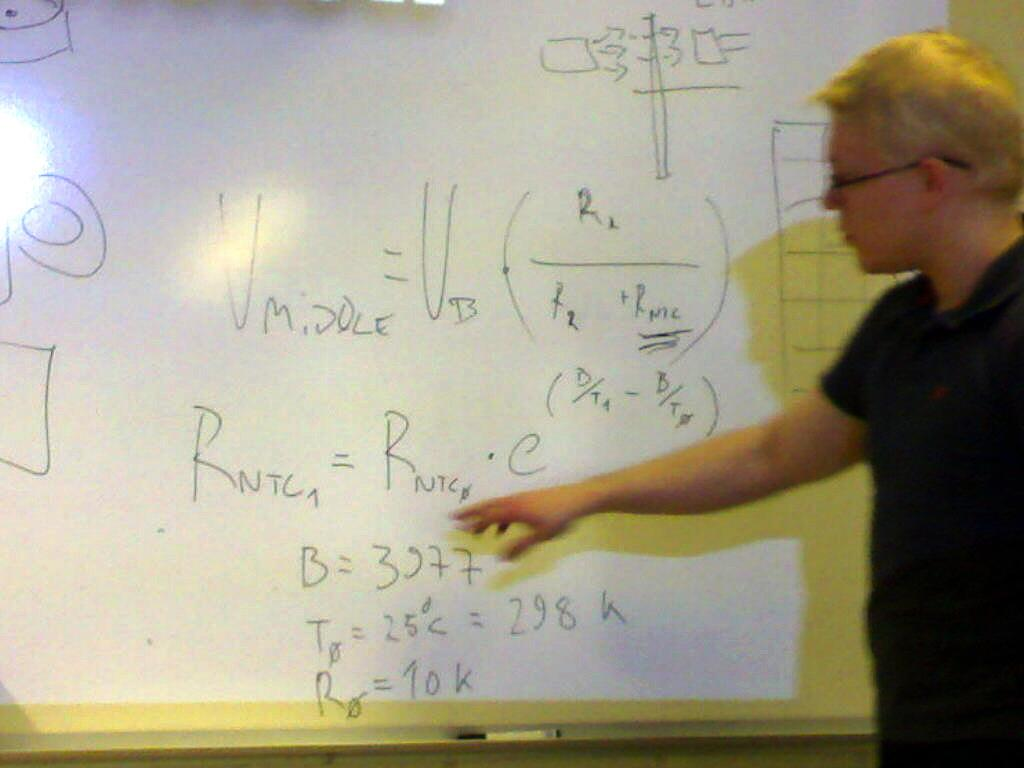Provide a one-sentence caption for the provided image. In the equation on the board B is equal to 3977. 